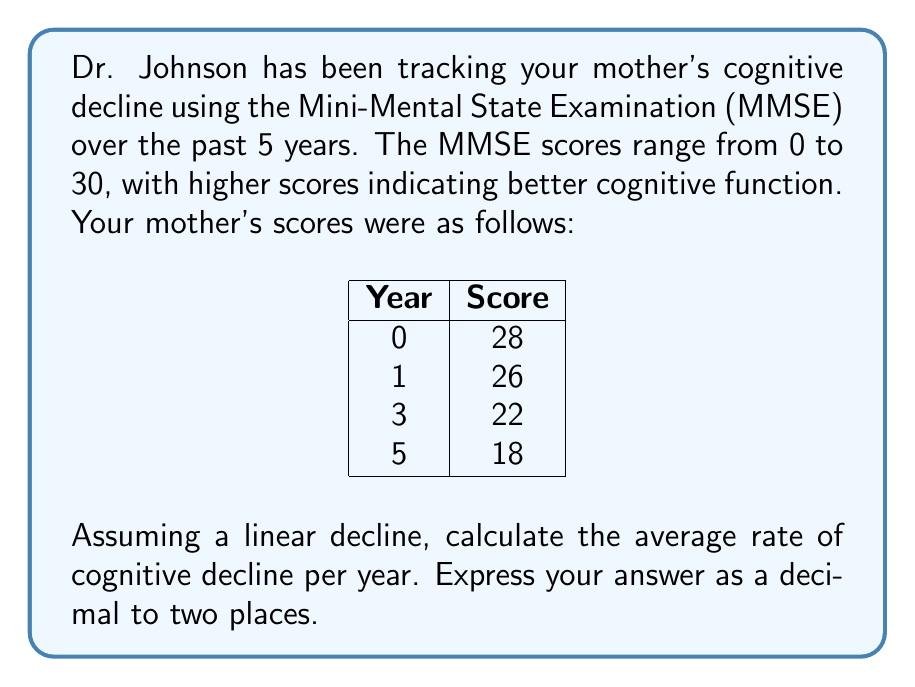Show me your answer to this math problem. To calculate the average rate of cognitive decline per year, we need to follow these steps:

1. Determine the total change in MMSE score:
   Initial score (Year 0) = 28
   Final score (Year 5) = 18
   Total change = 28 - 18 = 10 points

2. Determine the time period:
   Time period = 5 years

3. Calculate the average rate of decline per year:
   Rate of decline = Total change / Time period
   
   $$ \text{Rate of decline} = \frac{\text{Total change}}{\text{Time period}} = \frac{10 \text{ points}}{5 \text{ years}} = 2 \text{ points/year} $$

4. Express the answer as a decimal to two places:
   2 points/year = 2.00 points/year

This calculation assumes a linear decline, which means we're assuming the rate of decline is constant over the 5-year period. In reality, cognitive decline in Alzheimer's disease may not always follow a perfectly linear pattern, but this linear approximation can be useful for understanding the overall trend.

It's important to note that while we have data points for years 0, 1, 3, and 5, we're using the total change over the entire 5-year period to calculate the average rate of decline. This approach takes into account all available data points and provides an overall trend for the entire period.
Answer: 2.00 points/year 